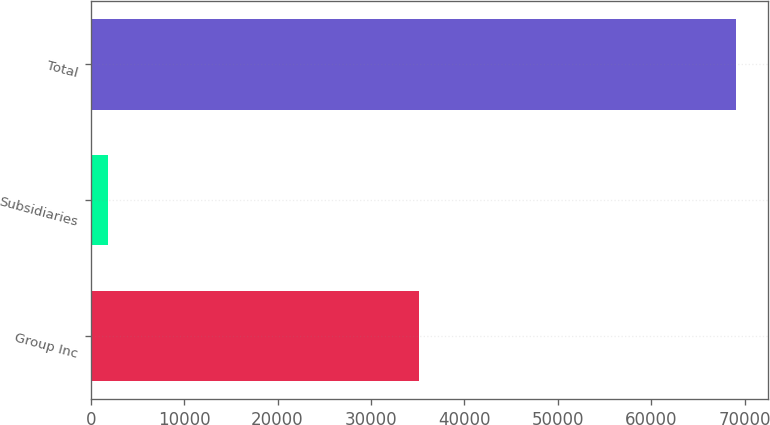Convert chart. <chart><loc_0><loc_0><loc_500><loc_500><bar_chart><fcel>Group Inc<fcel>Subsidiaries<fcel>Total<nl><fcel>35116<fcel>1859<fcel>69038<nl></chart> 